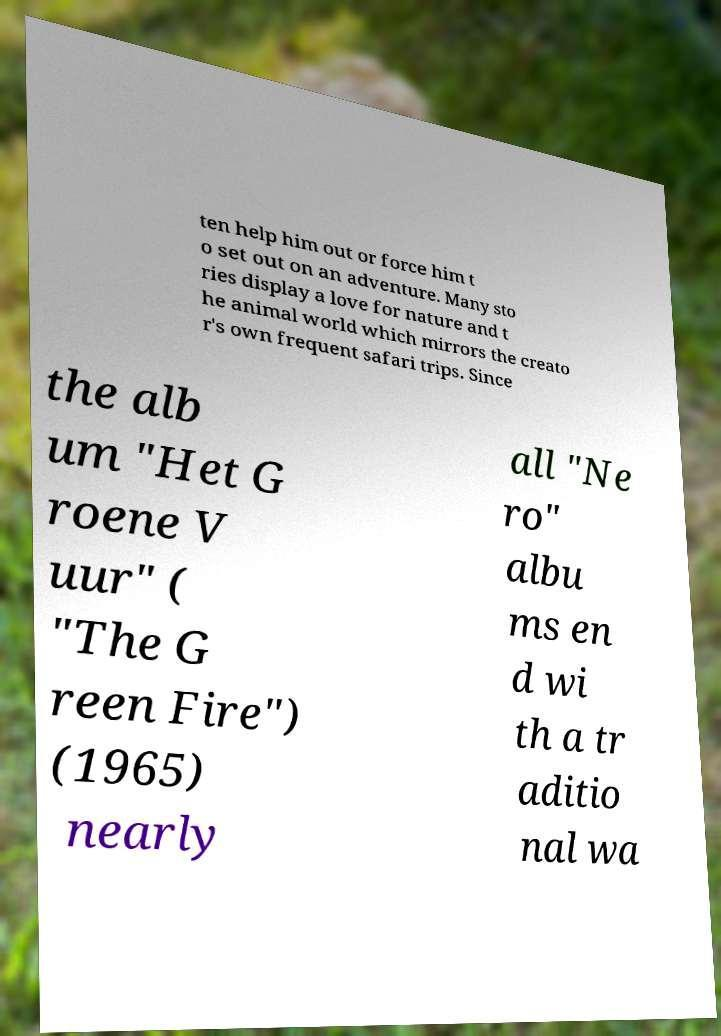Could you extract and type out the text from this image? ten help him out or force him t o set out on an adventure. Many sto ries display a love for nature and t he animal world which mirrors the creato r's own frequent safari trips. Since the alb um "Het G roene V uur" ( "The G reen Fire") (1965) nearly all "Ne ro" albu ms en d wi th a tr aditio nal wa 